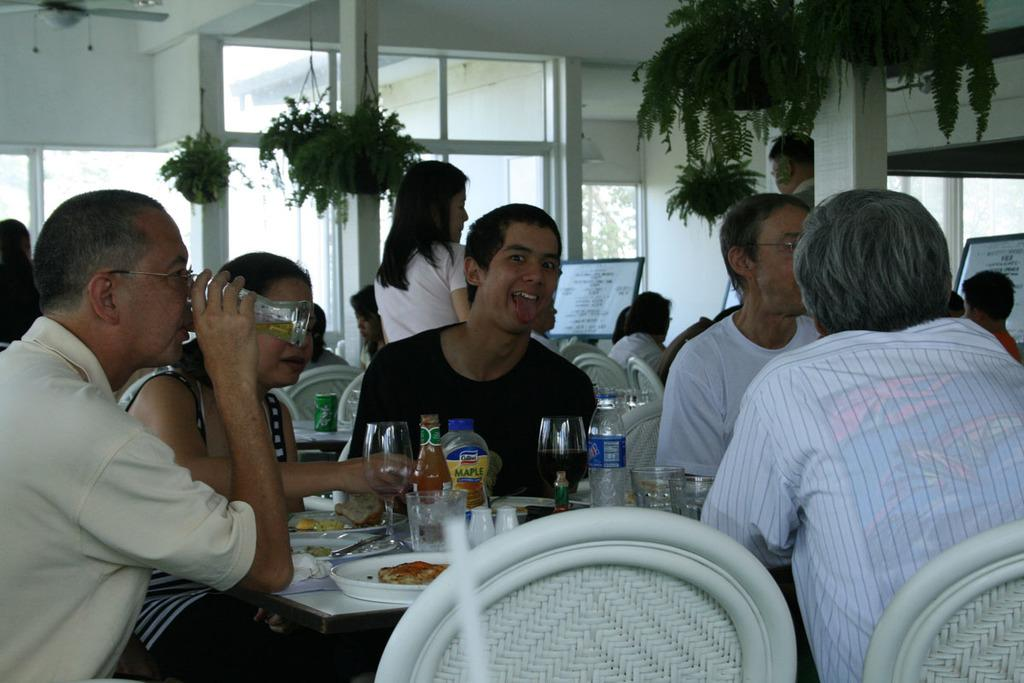How many people are in the image? There is a group of people in the image, but the exact number is not specified. What are the people doing in the image? The people are sitting on chairs in the image. What is in front of the people? There is a table in front of the people. What is on the table? The people have plates of food on the table. What else can be seen on the table? There are glasses and bottles of water on the table. What can be seen in the background of the image? Plants are visible in the background of the image. Can you describe the hen that is flying in the image? There is no hen present in the image, nor is there any indication of a hen flying. 